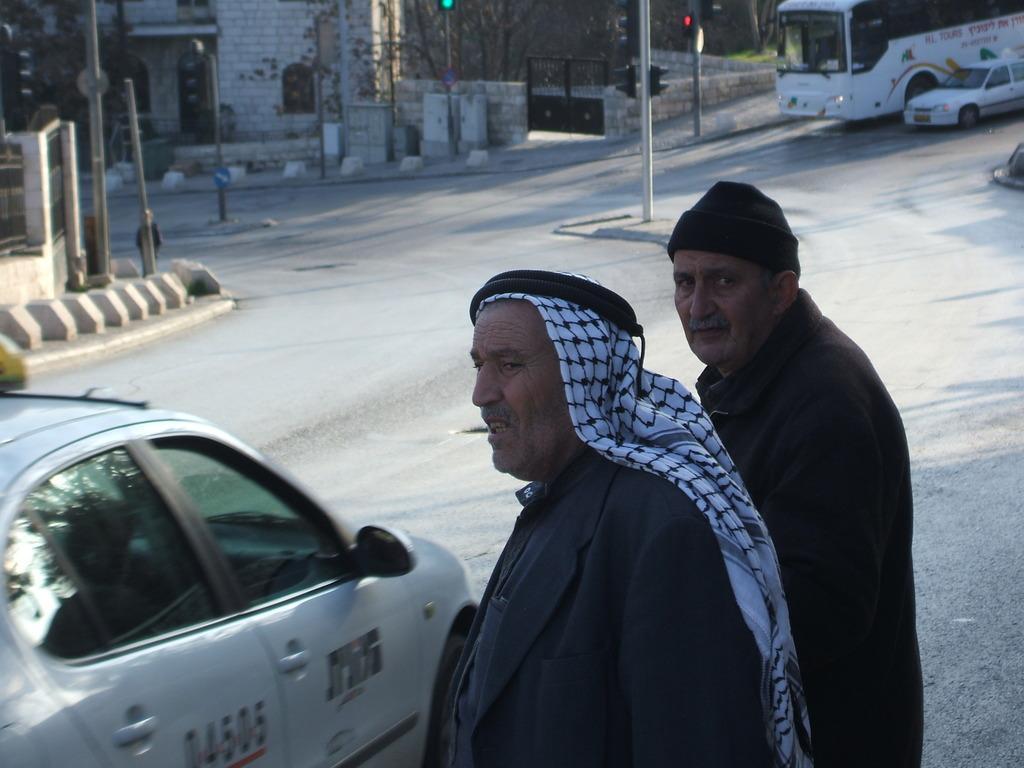In one or two sentences, can you explain what this image depicts? In this image we can see two men are standing on the road. One man is wearing coat with a white scarf and the other man is wearing coat and black cap. In front of them, one car is there. At the top of the image we can see poles, trees, boundary wall, gate, building, bus and car. 